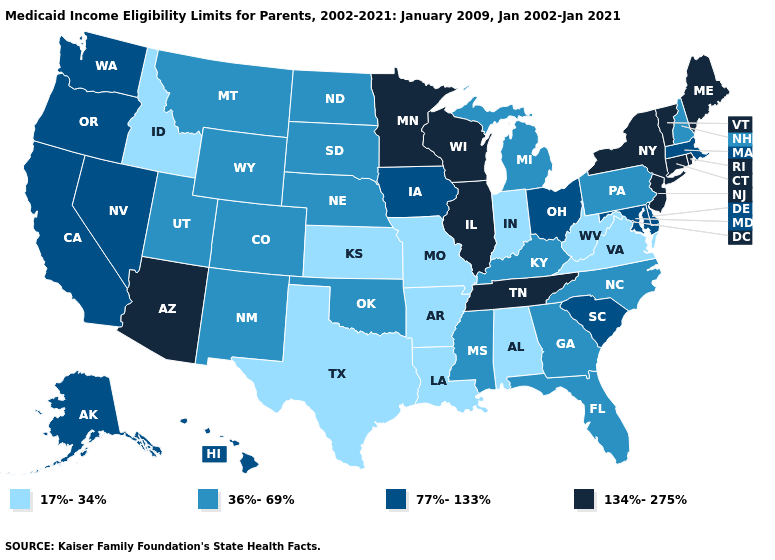Does Virginia have the same value as Idaho?
Quick response, please. Yes. Name the states that have a value in the range 134%-275%?
Concise answer only. Arizona, Connecticut, Illinois, Maine, Minnesota, New Jersey, New York, Rhode Island, Tennessee, Vermont, Wisconsin. What is the lowest value in the USA?
Quick response, please. 17%-34%. What is the highest value in states that border Colorado?
Give a very brief answer. 134%-275%. How many symbols are there in the legend?
Answer briefly. 4. Among the states that border Delaware , which have the highest value?
Write a very short answer. New Jersey. Name the states that have a value in the range 36%-69%?
Give a very brief answer. Colorado, Florida, Georgia, Kentucky, Michigan, Mississippi, Montana, Nebraska, New Hampshire, New Mexico, North Carolina, North Dakota, Oklahoma, Pennsylvania, South Dakota, Utah, Wyoming. What is the value of Michigan?
Concise answer only. 36%-69%. Does Arizona have the highest value in the USA?
Short answer required. Yes. Does Colorado have a higher value than West Virginia?
Concise answer only. Yes. Does North Carolina have the highest value in the USA?
Answer briefly. No. Does Louisiana have the lowest value in the USA?
Concise answer only. Yes. What is the highest value in the USA?
Be succinct. 134%-275%. What is the lowest value in states that border Utah?
Concise answer only. 17%-34%. 